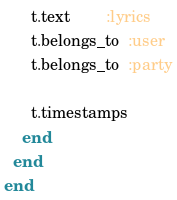Convert code to text. <code><loc_0><loc_0><loc_500><loc_500><_Ruby_>      t.text        :lyrics
      t.belongs_to  :user
      t.belongs_to  :party

      t.timestamps
    end
  end
end
</code> 